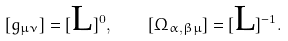Convert formula to latex. <formula><loc_0><loc_0><loc_500><loc_500>[ g _ { \mu \nu } ] = [ \text {L} ] ^ { 0 } , \quad [ \Omega _ { \alpha , \beta \mu } ] = [ \text {L} ] ^ { - 1 } .</formula> 